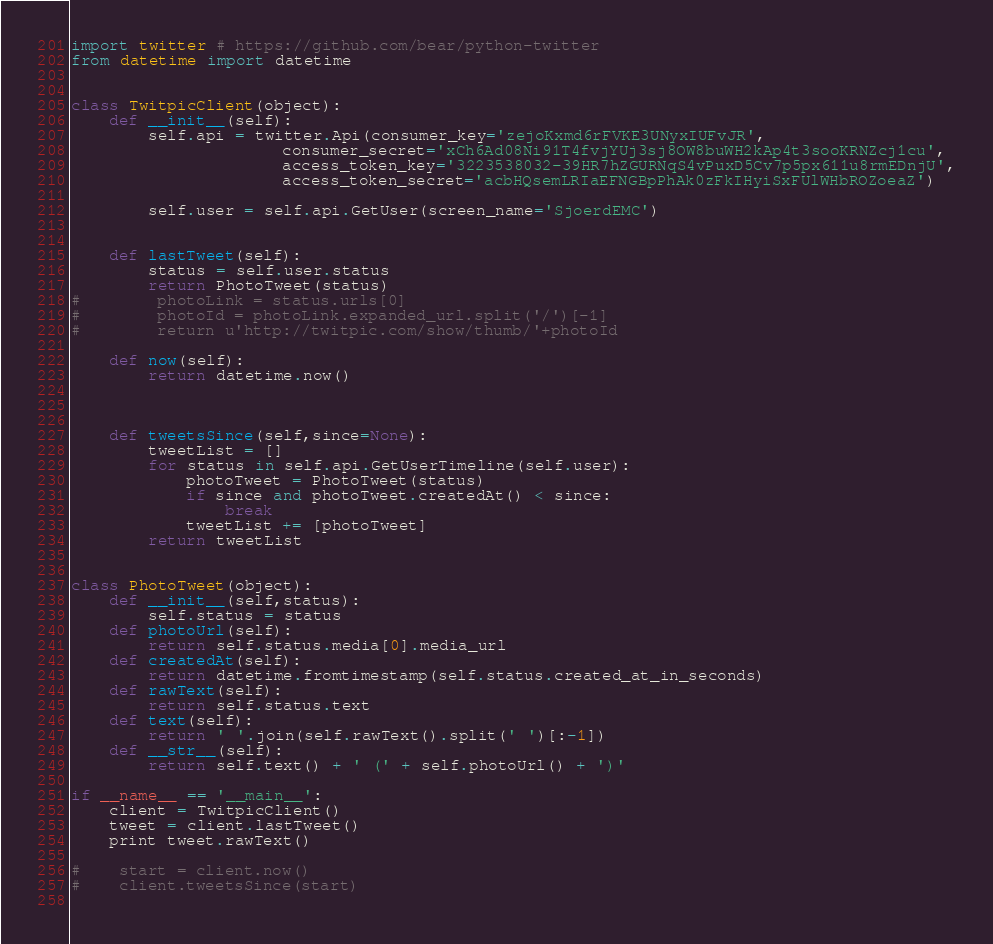<code> <loc_0><loc_0><loc_500><loc_500><_Python_>import twitter # https://github.com/bear/python-twitter
from datetime import datetime


class TwitpicClient(object):
    def __init__(self):
        self.api = twitter.Api(consumer_key='zejoKxmd6rFVKE3UNyxIUFvJR',
                      consumer_secret='xCh6Ad08Ni91T4fvjYUj3sj8OW8buWH2kAp4t3sooKRNZcj1cu',
                      access_token_key='3223538032-39HR7hZGURNqS4vPuxD5Cv7p5px611u8rmEDnjU',
                      access_token_secret='acbHQsemLRIaEFNGBpPhAk0zFkIHyiSxFUlWHbROZoeaZ')
                      
        self.user = self.api.GetUser(screen_name='SjoerdEMC')

  
    def lastTweet(self):
        status = self.user.status
        return PhotoTweet(status)
#        photoLink = status.urls[0]
#        photoId = photoLink.expanded_url.split('/')[-1]              
#        return u'http://twitpic.com/show/thumb/'+photoId
    
    def now(self):
        return datetime.now()

        
    
    def tweetsSince(self,since=None):
        tweetList = []
        for status in self.api.GetUserTimeline(self.user):
            photoTweet = PhotoTweet(status)
            if since and photoTweet.createdAt() < since:
                break
            tweetList += [photoTweet]
        return tweetList
    

class PhotoTweet(object):
    def __init__(self,status):
        self.status = status
    def photoUrl(self):                
        return self.status.media[0].media_url
    def createdAt(self):
        return datetime.fromtimestamp(self.status.created_at_in_seconds)
    def rawText(self):
        return self.status.text
    def text(self):
        return ' '.join(self.rawText().split(' ')[:-1])
    def __str__(self):
        return self.text() + ' (' + self.photoUrl() + ')'

if __name__ == '__main__':
    client = TwitpicClient()
    tweet = client.lastTweet()
    print tweet.rawText()
    
#    start = client.now()
#    client.tweetsSince(start)
    
</code> 